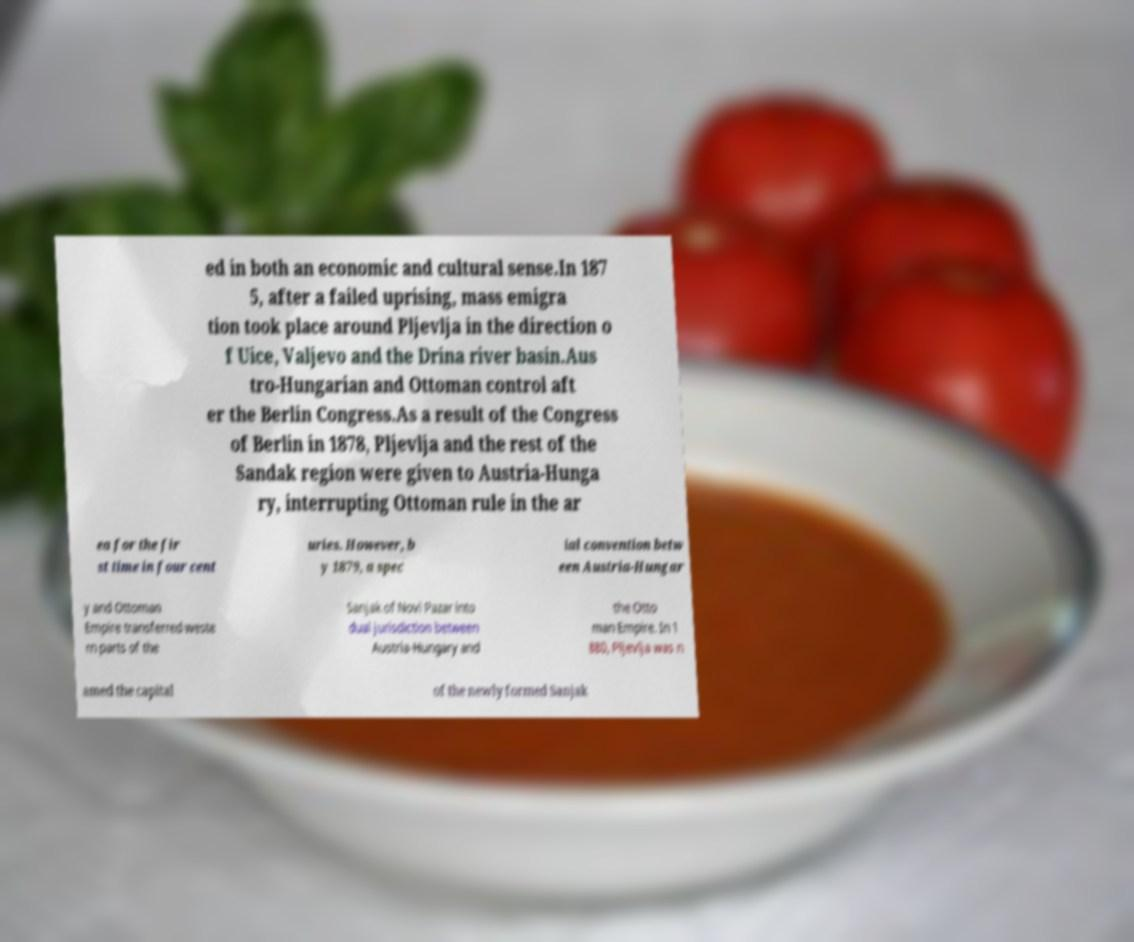There's text embedded in this image that I need extracted. Can you transcribe it verbatim? ed in both an economic and cultural sense.In 187 5, after a failed uprising, mass emigra tion took place around Pljevlja in the direction o f Uice, Valjevo and the Drina river basin.Aus tro-Hungarian and Ottoman control aft er the Berlin Congress.As a result of the Congress of Berlin in 1878, Pljevlja and the rest of the Sandak region were given to Austria-Hunga ry, interrupting Ottoman rule in the ar ea for the fir st time in four cent uries. However, b y 1879, a spec ial convention betw een Austria-Hungar y and Ottoman Empire transferred weste rn parts of the Sanjak of Novi Pazar into dual jurisdiction between Austria-Hungary and the Otto man Empire. In 1 880, Pljevlja was n amed the capital of the newly formed Sanjak 